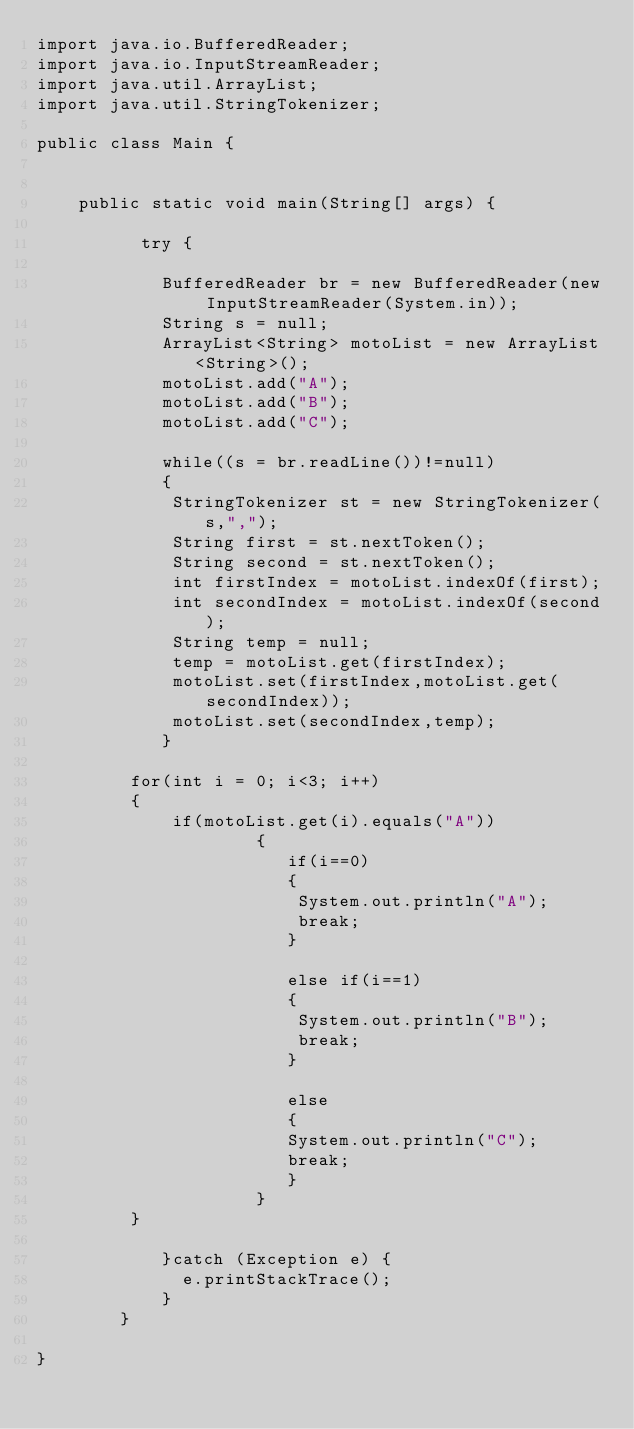Convert code to text. <code><loc_0><loc_0><loc_500><loc_500><_Java_>import java.io.BufferedReader;
import java.io.InputStreamReader;
import java.util.ArrayList;
import java.util.StringTokenizer;
   
public class Main {
       
     
    public static void main(String[] args) {
            
          try {
                 
        	BufferedReader br = new BufferedReader(new InputStreamReader(System.in));  
            String s = null;
            ArrayList<String> motoList = new ArrayList<String>();
            motoList.add("A");
            motoList.add("B");
            motoList.add("C");
            
            while((s = br.readLine())!=null)
            {
       		 StringTokenizer st = new StringTokenizer(s,",");
       		 String first = st.nextToken();
       		 String second = st.nextToken();
       		 int firstIndex = motoList.indexOf(first);
       		 int secondIndex = motoList.indexOf(second);
       		 String temp = null;
       		 temp = motoList.get(firstIndex);
       		 motoList.set(firstIndex,motoList.get(secondIndex));
       		 motoList.set(secondIndex,temp);
            }
       	
       	 for(int i = 0; i<3; i++)
       	 {
       		 if(motoList.get(i).equals("A"))
       				 {
       			 		if(i==0)
       			 		{
       			 		 System.out.println("A");
       			 		 break;
       			 		}
       			 		
       			 		else if(i==1)
       			 		{
       			 		 System.out.println("B");
       			 		 break;
       			 		}
       			 		
       			 		else
       			 		{
       			 		System.out.println("C");
       			 		break;
       			 		}
       				 }
       	 }
       
            }catch (Exception e) {
              e.printStackTrace();
            }
        }
     
}
    </code> 